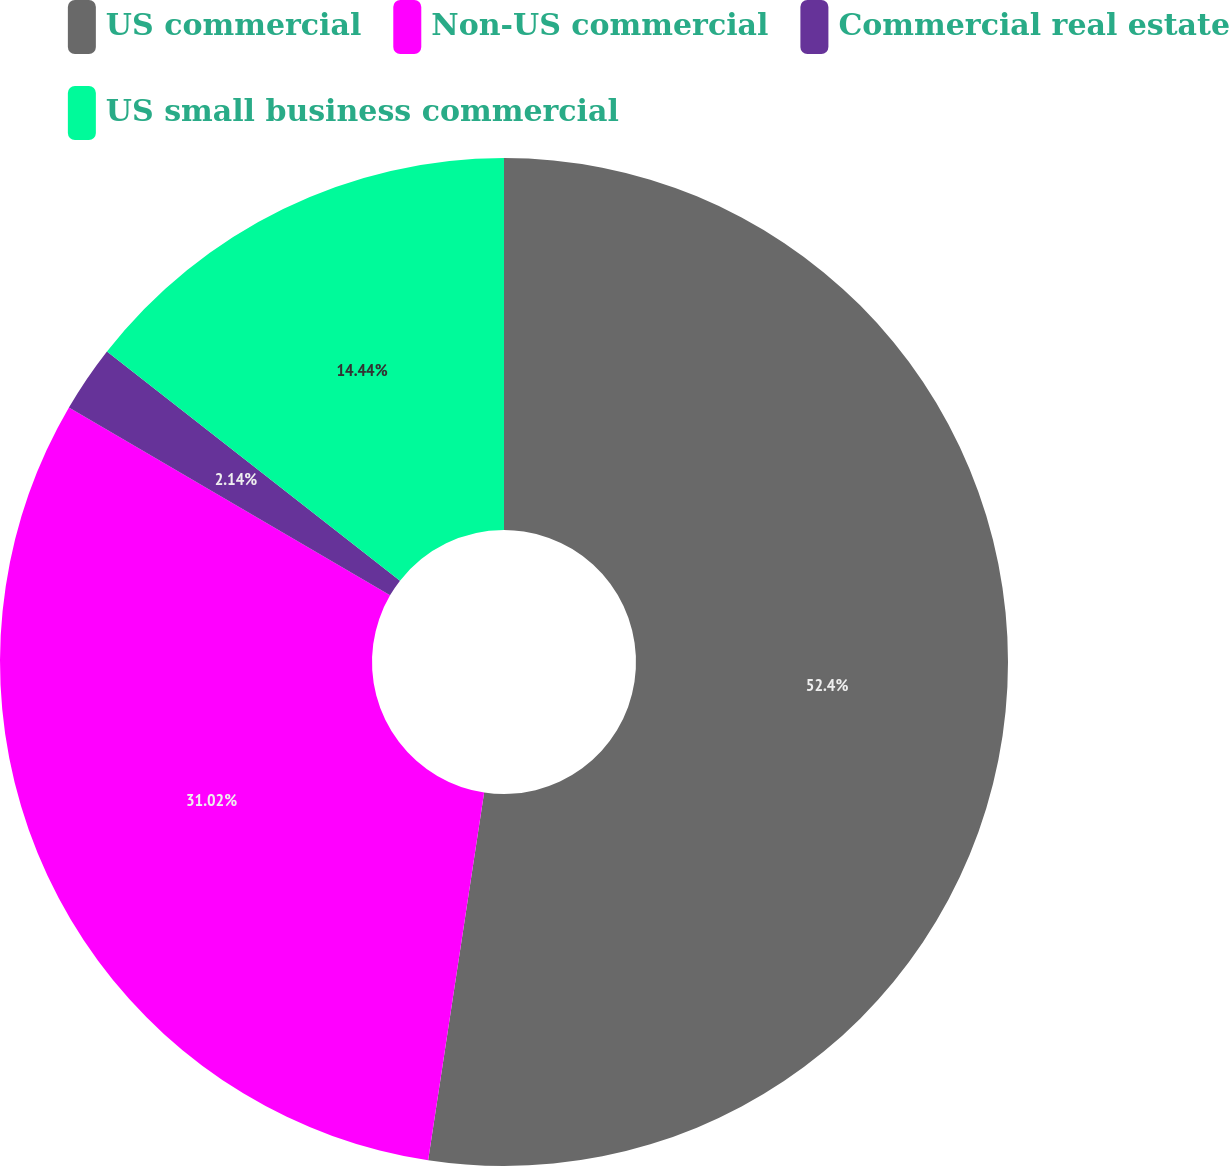Convert chart. <chart><loc_0><loc_0><loc_500><loc_500><pie_chart><fcel>US commercial<fcel>Non-US commercial<fcel>Commercial real estate<fcel>US small business commercial<nl><fcel>52.41%<fcel>31.02%<fcel>2.14%<fcel>14.44%<nl></chart> 